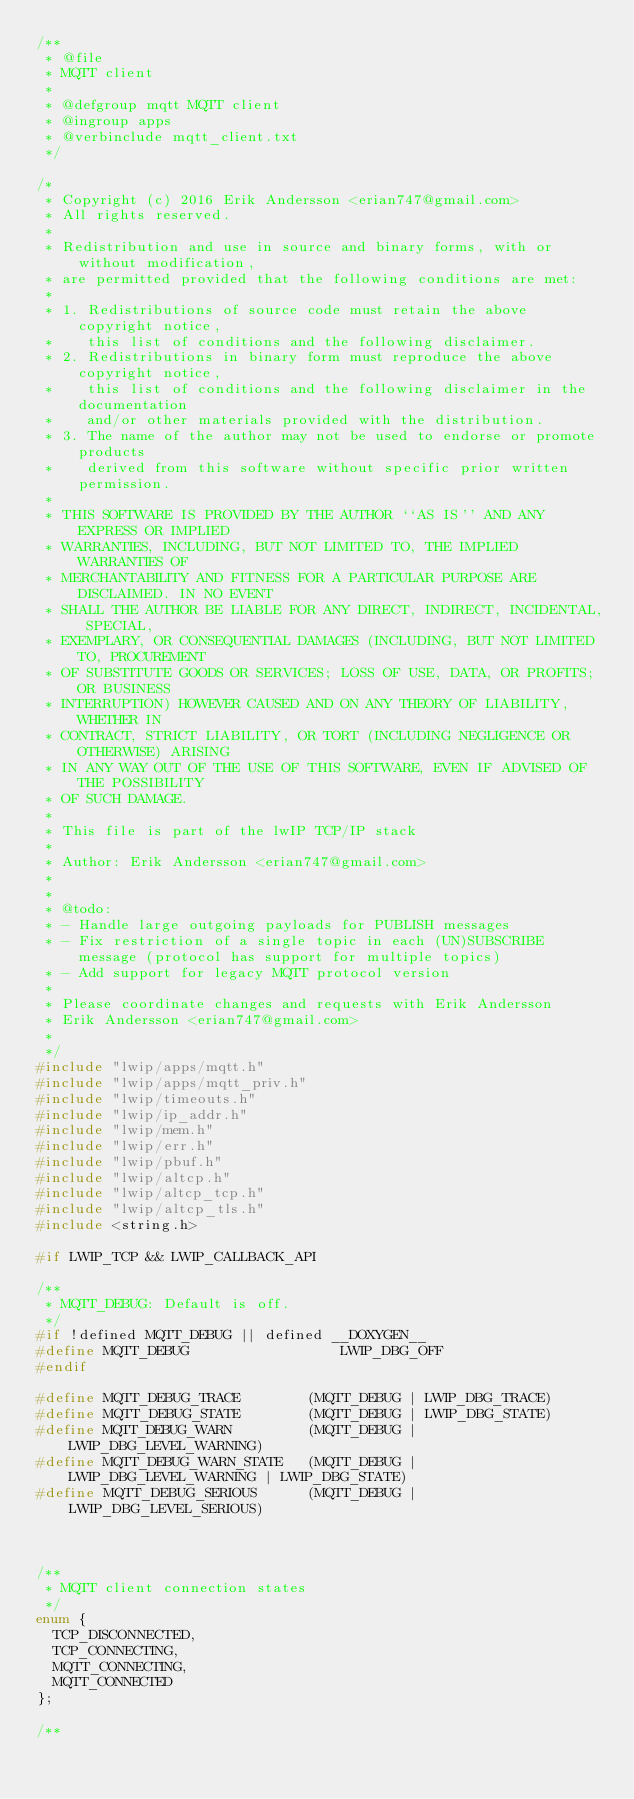<code> <loc_0><loc_0><loc_500><loc_500><_C_>/**
 * @file
 * MQTT client
 *
 * @defgroup mqtt MQTT client
 * @ingroup apps
 * @verbinclude mqtt_client.txt
 */

/*
 * Copyright (c) 2016 Erik Andersson <erian747@gmail.com>
 * All rights reserved.
 *
 * Redistribution and use in source and binary forms, with or without modification,
 * are permitted provided that the following conditions are met:
 *
 * 1. Redistributions of source code must retain the above copyright notice,
 *    this list of conditions and the following disclaimer.
 * 2. Redistributions in binary form must reproduce the above copyright notice,
 *    this list of conditions and the following disclaimer in the documentation
 *    and/or other materials provided with the distribution.
 * 3. The name of the author may not be used to endorse or promote products
 *    derived from this software without specific prior written permission.
 *
 * THIS SOFTWARE IS PROVIDED BY THE AUTHOR ``AS IS'' AND ANY EXPRESS OR IMPLIED
 * WARRANTIES, INCLUDING, BUT NOT LIMITED TO, THE IMPLIED WARRANTIES OF
 * MERCHANTABILITY AND FITNESS FOR A PARTICULAR PURPOSE ARE DISCLAIMED. IN NO EVENT
 * SHALL THE AUTHOR BE LIABLE FOR ANY DIRECT, INDIRECT, INCIDENTAL, SPECIAL,
 * EXEMPLARY, OR CONSEQUENTIAL DAMAGES (INCLUDING, BUT NOT LIMITED TO, PROCUREMENT
 * OF SUBSTITUTE GOODS OR SERVICES; LOSS OF USE, DATA, OR PROFITS; OR BUSINESS
 * INTERRUPTION) HOWEVER CAUSED AND ON ANY THEORY OF LIABILITY, WHETHER IN
 * CONTRACT, STRICT LIABILITY, OR TORT (INCLUDING NEGLIGENCE OR OTHERWISE) ARISING
 * IN ANY WAY OUT OF THE USE OF THIS SOFTWARE, EVEN IF ADVISED OF THE POSSIBILITY
 * OF SUCH DAMAGE.
 *
 * This file is part of the lwIP TCP/IP stack
 *
 * Author: Erik Andersson <erian747@gmail.com>
 *
 *
 * @todo:
 * - Handle large outgoing payloads for PUBLISH messages
 * - Fix restriction of a single topic in each (UN)SUBSCRIBE message (protocol has support for multiple topics)
 * - Add support for legacy MQTT protocol version
 *
 * Please coordinate changes and requests with Erik Andersson
 * Erik Andersson <erian747@gmail.com>
 *
 */
#include "lwip/apps/mqtt.h"
#include "lwip/apps/mqtt_priv.h"
#include "lwip/timeouts.h"
#include "lwip/ip_addr.h"
#include "lwip/mem.h"
#include "lwip/err.h"
#include "lwip/pbuf.h"
#include "lwip/altcp.h"
#include "lwip/altcp_tcp.h"
#include "lwip/altcp_tls.h"
#include <string.h>

#if LWIP_TCP && LWIP_CALLBACK_API

/**
 * MQTT_DEBUG: Default is off.
 */
#if !defined MQTT_DEBUG || defined __DOXYGEN__
#define MQTT_DEBUG                  LWIP_DBG_OFF
#endif

#define MQTT_DEBUG_TRACE        (MQTT_DEBUG | LWIP_DBG_TRACE)
#define MQTT_DEBUG_STATE        (MQTT_DEBUG | LWIP_DBG_STATE)
#define MQTT_DEBUG_WARN         (MQTT_DEBUG | LWIP_DBG_LEVEL_WARNING)
#define MQTT_DEBUG_WARN_STATE   (MQTT_DEBUG | LWIP_DBG_LEVEL_WARNING | LWIP_DBG_STATE)
#define MQTT_DEBUG_SERIOUS      (MQTT_DEBUG | LWIP_DBG_LEVEL_SERIOUS)



/**
 * MQTT client connection states
 */
enum {
  TCP_DISCONNECTED,
  TCP_CONNECTING,
  MQTT_CONNECTING,
  MQTT_CONNECTED
};

/**</code> 